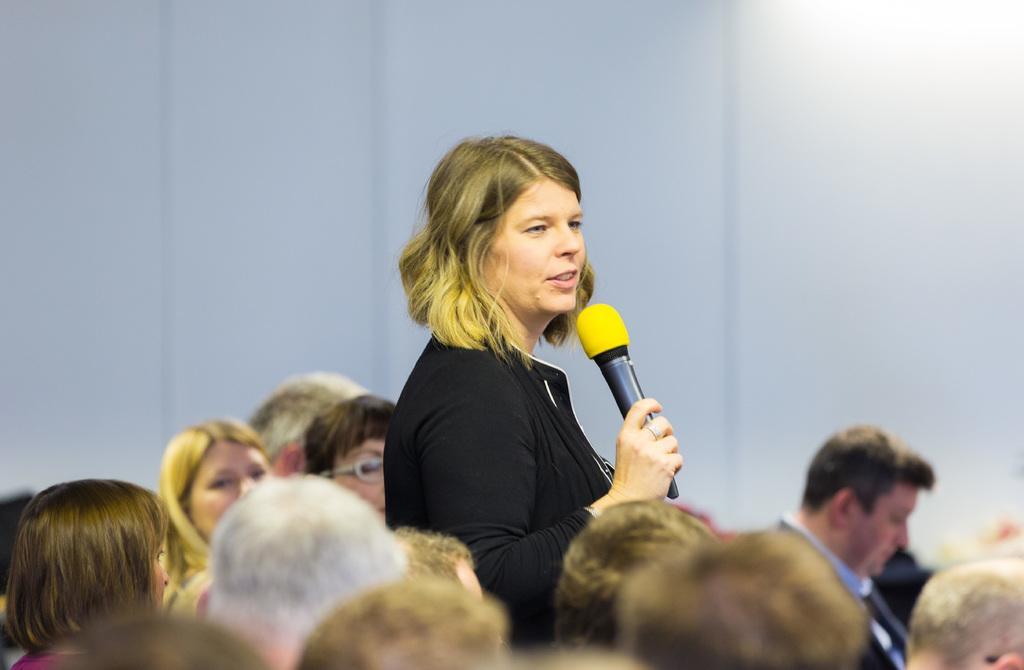Describe this image in one or two sentences. This is a picture of a woman standing and talking into microphone. This picture might be taken in a meeting. There are many people seated. The wall is painted white. 